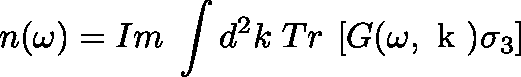Convert formula to latex. <formula><loc_0><loc_0><loc_500><loc_500>n ( \omega ) = I m \, \int d ^ { 2 } k \, T r \, \left [ G ( \omega , \boldmath k ) \sigma _ { 3 } \right ]</formula> 